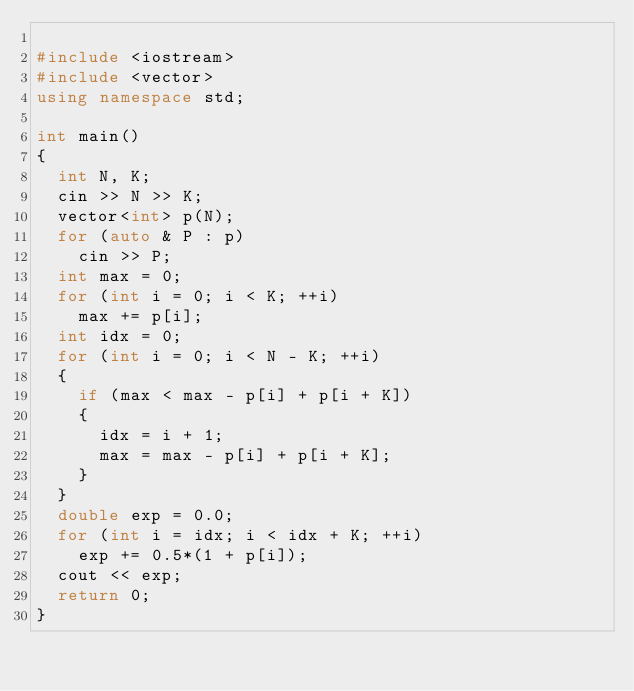<code> <loc_0><loc_0><loc_500><loc_500><_C++_>
#include <iostream>
#include <vector>
using namespace std;

int main()
{
  int N, K;
  cin >> N >> K;
  vector<int> p(N);
  for (auto & P : p)
    cin >> P;
  int max = 0;
  for (int i = 0; i < K; ++i)
    max += p[i];
  int idx = 0;
  for (int i = 0; i < N - K; ++i)
  {
    if (max < max - p[i] + p[i + K])
    {
      idx = i + 1;
      max = max - p[i] + p[i + K];
    }
  }
  double exp = 0.0;
  for (int i = idx; i < idx + K; ++i)
    exp += 0.5*(1 + p[i]);
  cout << exp;
  return 0;
}
</code> 